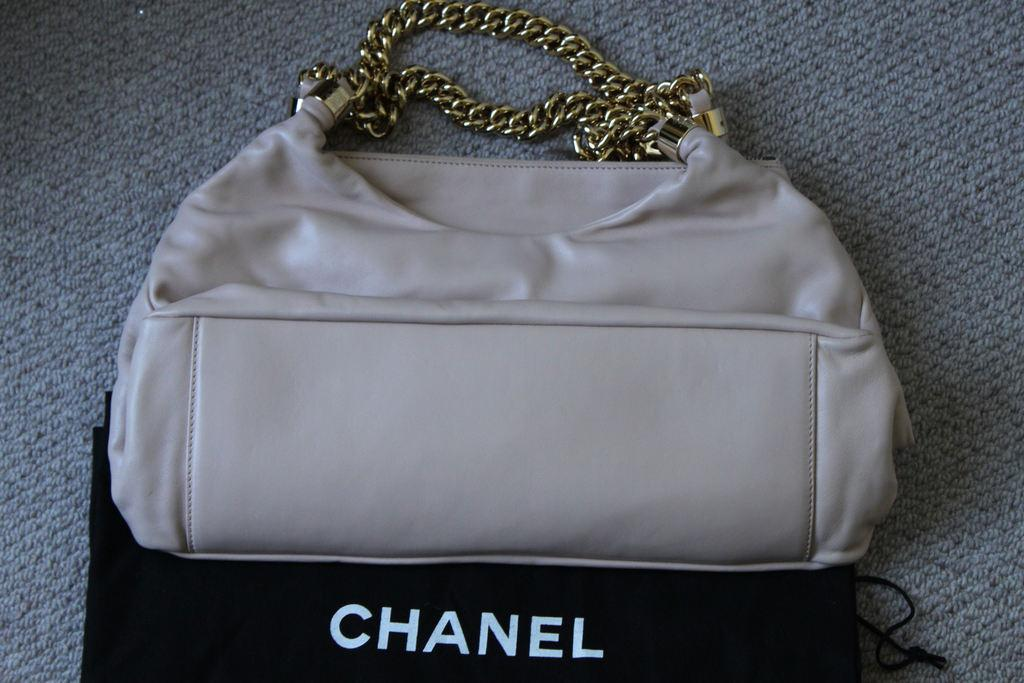What is the main object in the center of the image? There is a cream-colored handbag in the center of the image. What feature is unique to the handbag? Chains are attached to the handle of the handbag. What can be seen in the background of the image? There is a mat in the background of the image. What type of plate is used to serve food on the mat in the image? There is no plate or food present in the image; it only features a cream-colored handbag with chains attached to the handle and a mat in the background. 